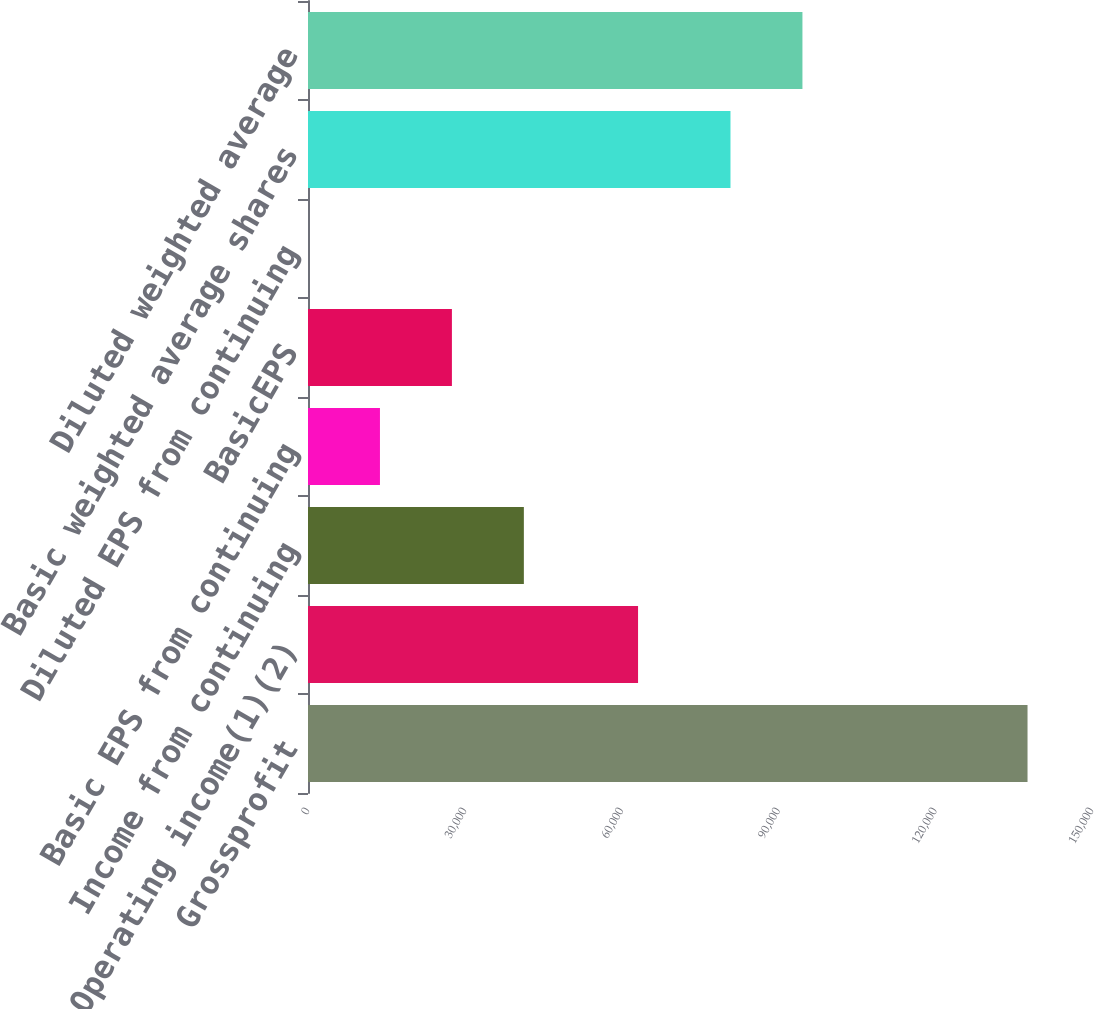<chart> <loc_0><loc_0><loc_500><loc_500><bar_chart><fcel>Grossprofit<fcel>Operating income(1)(2)<fcel>Income from continuing<fcel>Basic EPS from continuing<fcel>BasicEPS<fcel>Diluted EPS from continuing<fcel>Basic weighted average shares<fcel>Diluted weighted average<nl><fcel>137665<fcel>63148<fcel>41299.8<fcel>13766.9<fcel>27533.4<fcel>0.47<fcel>80832<fcel>94598.4<nl></chart> 